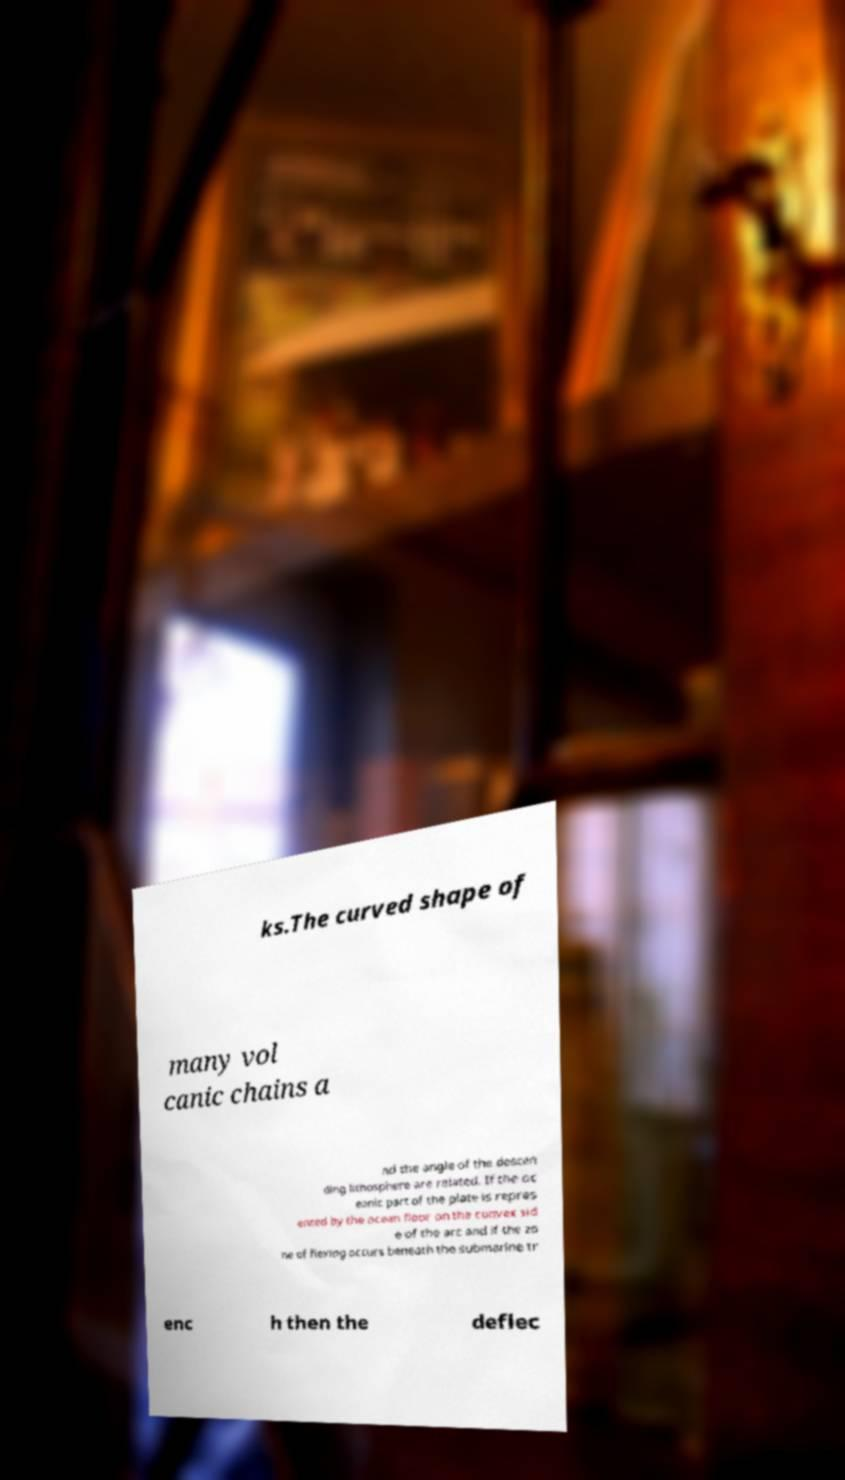What messages or text are displayed in this image? I need them in a readable, typed format. ks.The curved shape of many vol canic chains a nd the angle of the descen ding lithosphere are related. If the oc eanic part of the plate is repres ented by the ocean floor on the convex sid e of the arc and if the zo ne of flexing occurs beneath the submarine tr enc h then the deflec 